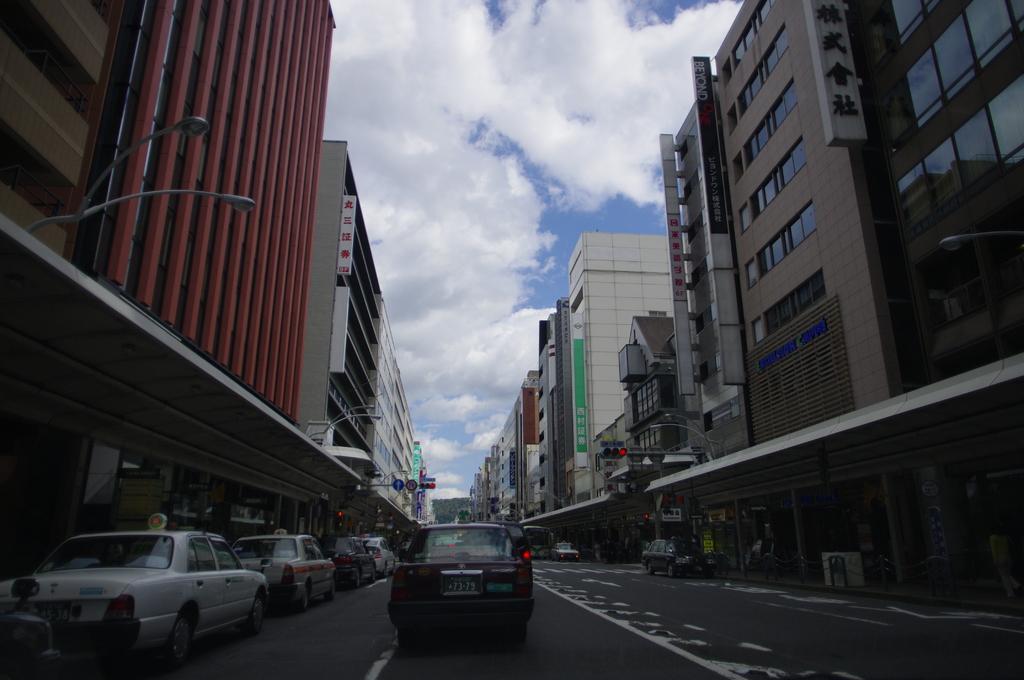Please provide a concise description of this image. In the center of the image we can see cars on the road and there are buildings. We can see poles. At the top there is sky. 